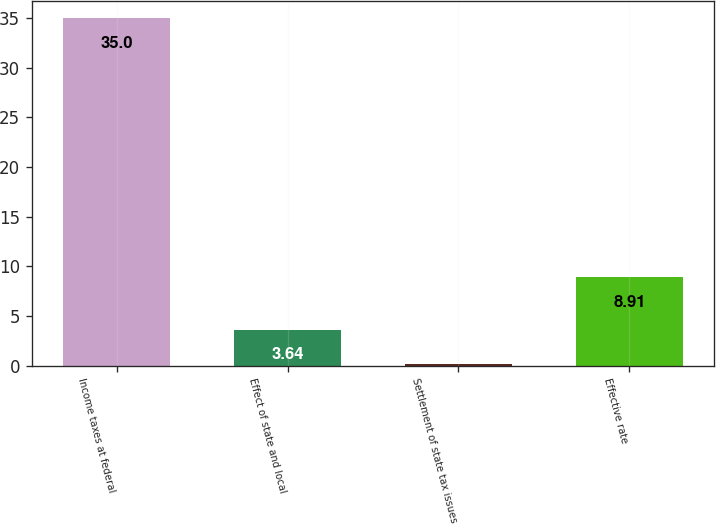Convert chart to OTSL. <chart><loc_0><loc_0><loc_500><loc_500><bar_chart><fcel>Income taxes at federal<fcel>Effect of state and local<fcel>Settlement of state tax issues<fcel>Effective rate<nl><fcel>35<fcel>3.64<fcel>0.15<fcel>8.91<nl></chart> 